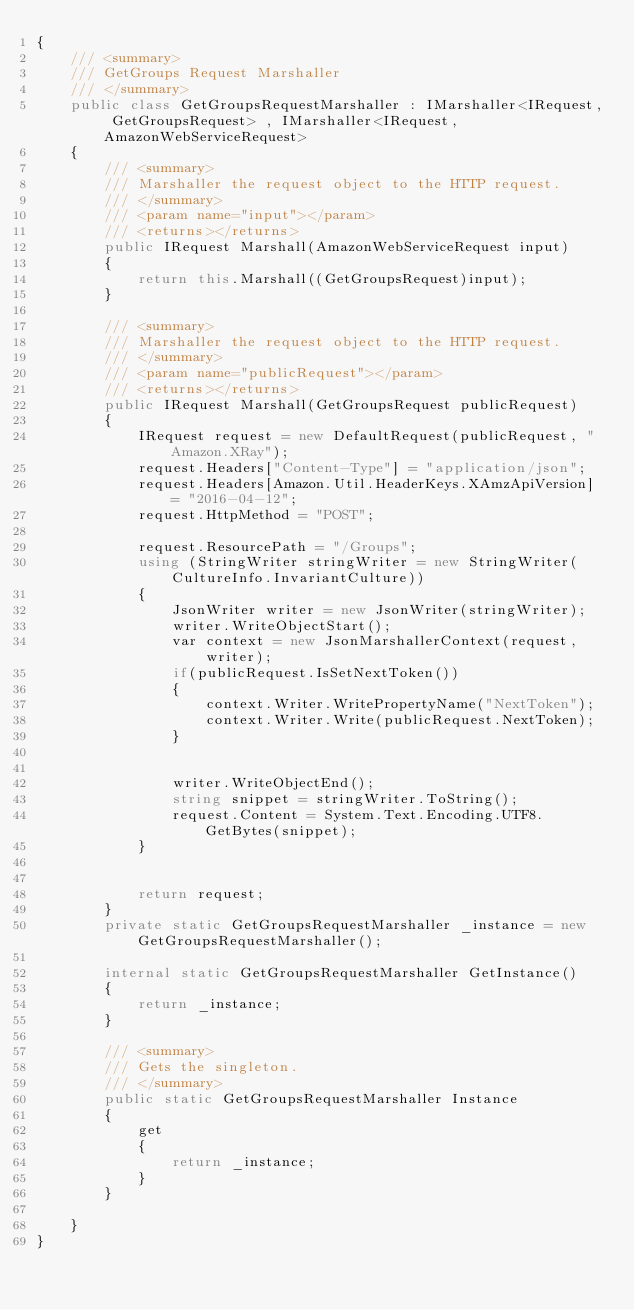Convert code to text. <code><loc_0><loc_0><loc_500><loc_500><_C#_>{
    /// <summary>
    /// GetGroups Request Marshaller
    /// </summary>       
    public class GetGroupsRequestMarshaller : IMarshaller<IRequest, GetGroupsRequest> , IMarshaller<IRequest,AmazonWebServiceRequest>
    {
        /// <summary>
        /// Marshaller the request object to the HTTP request.
        /// </summary>  
        /// <param name="input"></param>
        /// <returns></returns>
        public IRequest Marshall(AmazonWebServiceRequest input)
        {
            return this.Marshall((GetGroupsRequest)input);
        }

        /// <summary>
        /// Marshaller the request object to the HTTP request.
        /// </summary>  
        /// <param name="publicRequest"></param>
        /// <returns></returns>
        public IRequest Marshall(GetGroupsRequest publicRequest)
        {
            IRequest request = new DefaultRequest(publicRequest, "Amazon.XRay");
            request.Headers["Content-Type"] = "application/json";
            request.Headers[Amazon.Util.HeaderKeys.XAmzApiVersion] = "2016-04-12";            
            request.HttpMethod = "POST";

            request.ResourcePath = "/Groups";
            using (StringWriter stringWriter = new StringWriter(CultureInfo.InvariantCulture))
            {
                JsonWriter writer = new JsonWriter(stringWriter);
                writer.WriteObjectStart();
                var context = new JsonMarshallerContext(request, writer);
                if(publicRequest.IsSetNextToken())
                {
                    context.Writer.WritePropertyName("NextToken");
                    context.Writer.Write(publicRequest.NextToken);
                }

        
                writer.WriteObjectEnd();
                string snippet = stringWriter.ToString();
                request.Content = System.Text.Encoding.UTF8.GetBytes(snippet);
            }


            return request;
        }
        private static GetGroupsRequestMarshaller _instance = new GetGroupsRequestMarshaller();        

        internal static GetGroupsRequestMarshaller GetInstance()
        {
            return _instance;
        }

        /// <summary>
        /// Gets the singleton.
        /// </summary>  
        public static GetGroupsRequestMarshaller Instance
        {
            get
            {
                return _instance;
            }
        }

    }
}</code> 